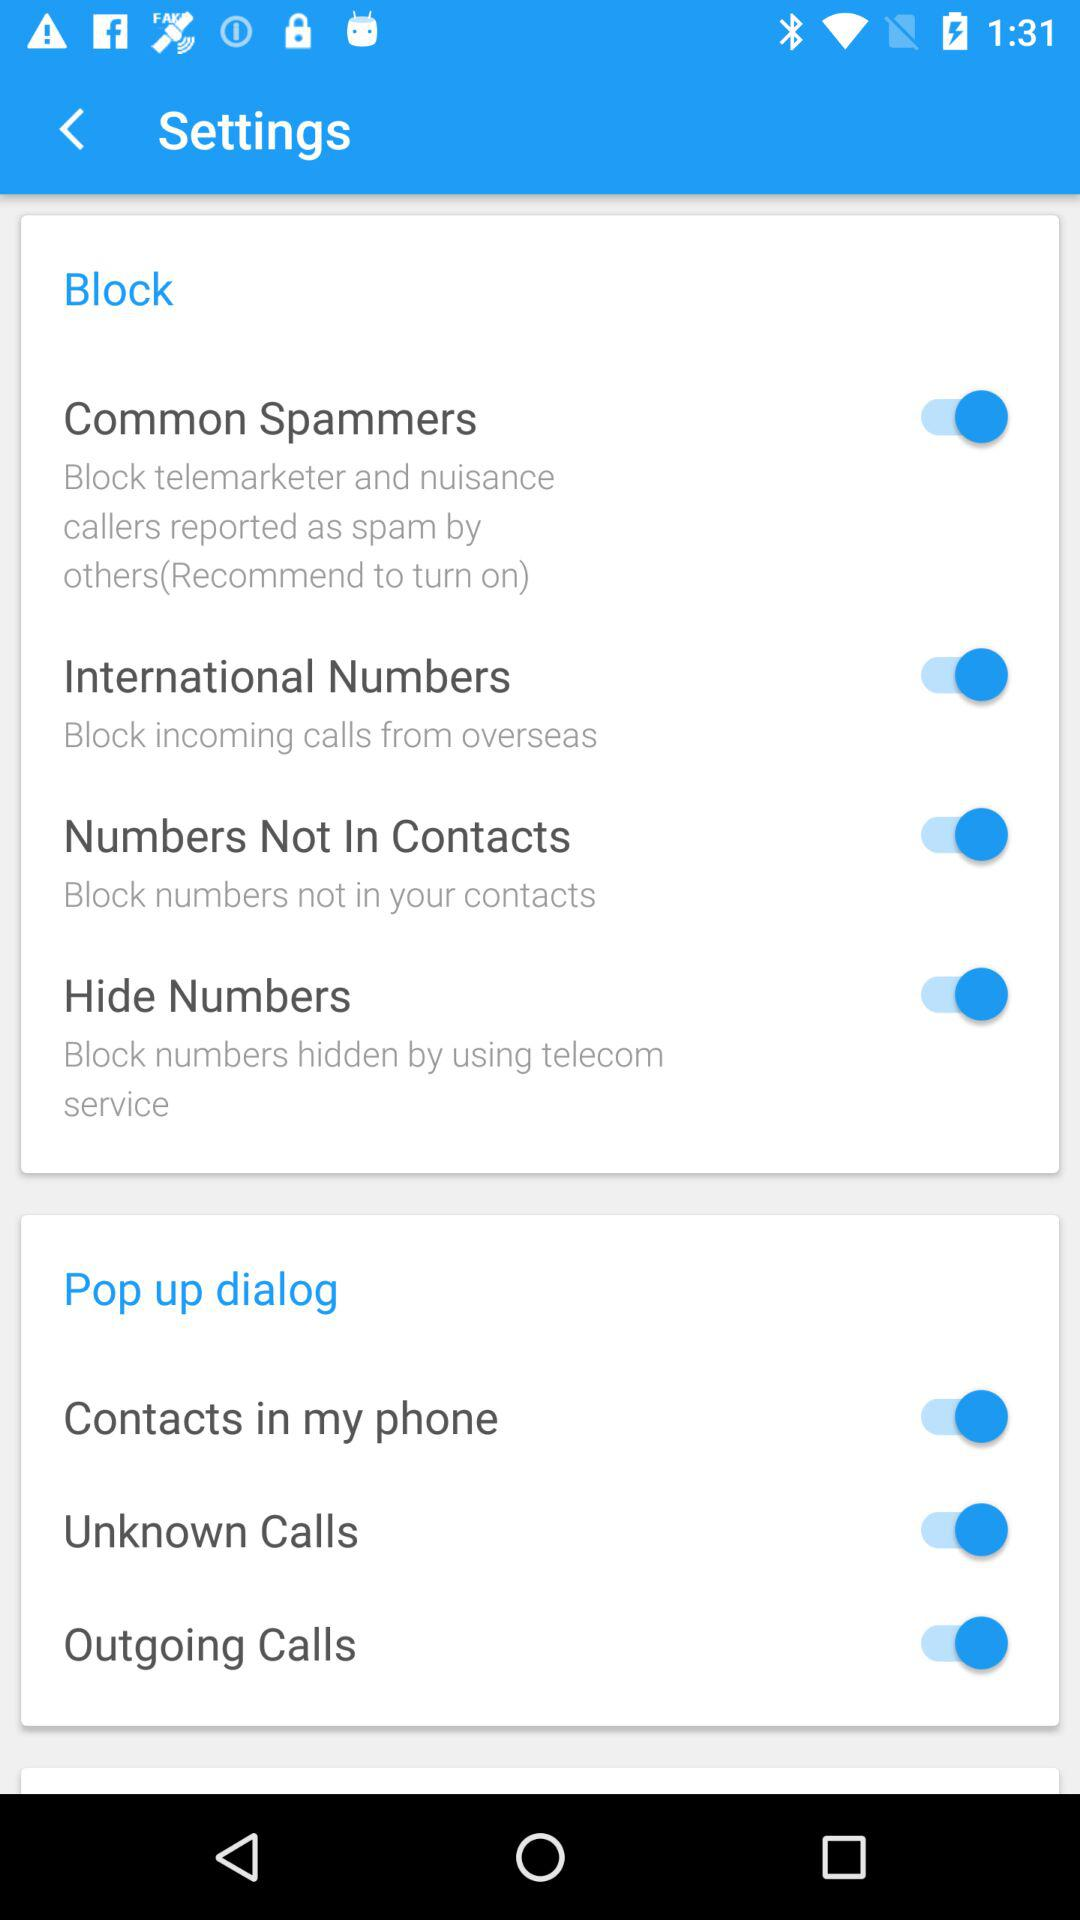What is the status of the "International Numbers"? The status of "International Numbers" is "on". 